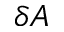<formula> <loc_0><loc_0><loc_500><loc_500>\delta A</formula> 